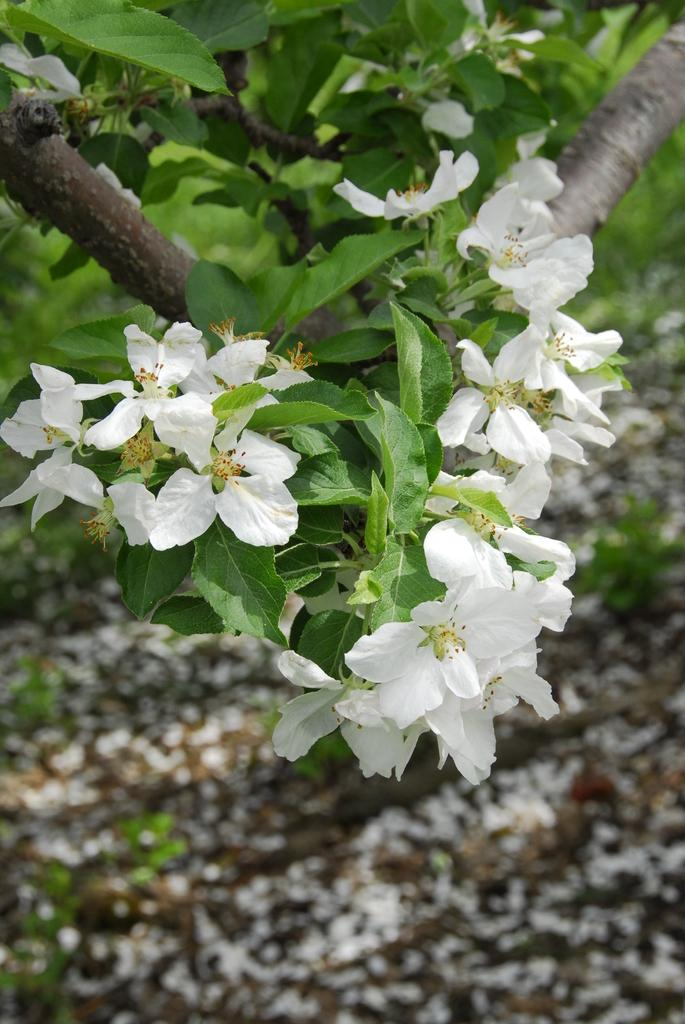What type of flowers can be seen in the foreground of the image? There are white flowers on a plant in the foreground of the image. Are there any flowers visible on the ground in the image? Yes, there are flowers on the ground in the image. What type of disgusting apparatus can be seen in the image? There is no disgusting apparatus present in the image. 